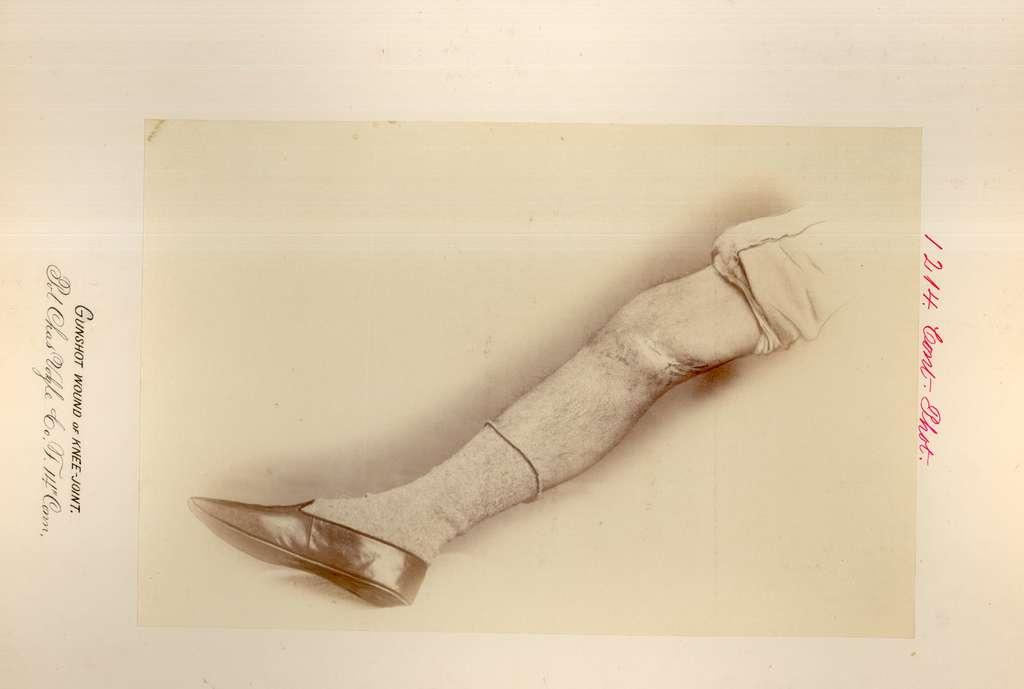What is depicted in the drawing in the image? There is a drawing of a human leg in the image. What is the leg wearing? The leg is wearing a shoe. What colors are mentioned on the paper? There are black and pink color words on the paper. What is the color of the background in the image? The background of the image is in cream color. What is the noise level in the image? There is no information about noise level in the image, as it is a drawing of a human leg. How much income does the person in the image earn? There is no information about income in the image, as it is a drawing of a human leg. 